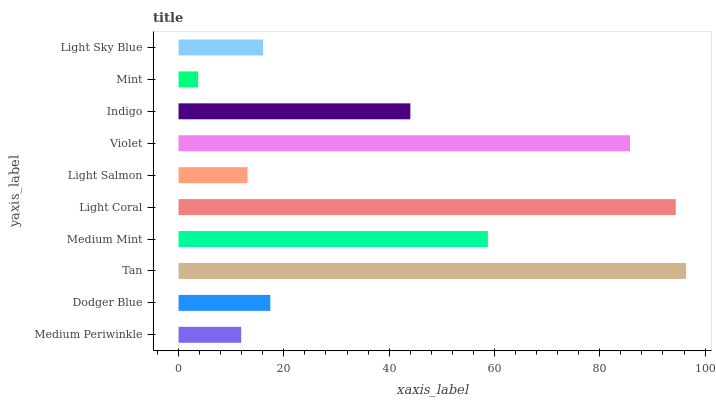Is Mint the minimum?
Answer yes or no. Yes. Is Tan the maximum?
Answer yes or no. Yes. Is Dodger Blue the minimum?
Answer yes or no. No. Is Dodger Blue the maximum?
Answer yes or no. No. Is Dodger Blue greater than Medium Periwinkle?
Answer yes or no. Yes. Is Medium Periwinkle less than Dodger Blue?
Answer yes or no. Yes. Is Medium Periwinkle greater than Dodger Blue?
Answer yes or no. No. Is Dodger Blue less than Medium Periwinkle?
Answer yes or no. No. Is Indigo the high median?
Answer yes or no. Yes. Is Dodger Blue the low median?
Answer yes or no. Yes. Is Tan the high median?
Answer yes or no. No. Is Tan the low median?
Answer yes or no. No. 